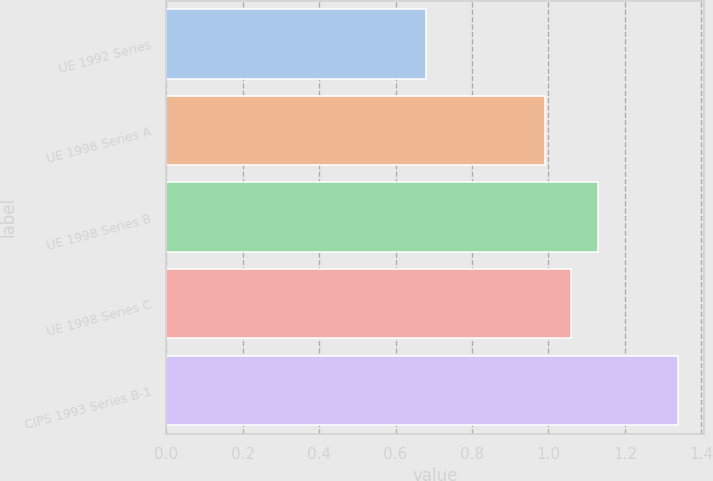<chart> <loc_0><loc_0><loc_500><loc_500><bar_chart><fcel>UE 1992 Series<fcel>UE 1998 Series A<fcel>UE 1998 Series B<fcel>UE 1998 Series C<fcel>CIPS 1993 Series B-1<nl><fcel>0.68<fcel>0.99<fcel>1.13<fcel>1.06<fcel>1.34<nl></chart> 